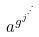Convert formula to latex. <formula><loc_0><loc_0><loc_500><loc_500>a ^ { g ^ { j ^ { \cdot ^ { \cdot ^ { \cdot } } } } }</formula> 